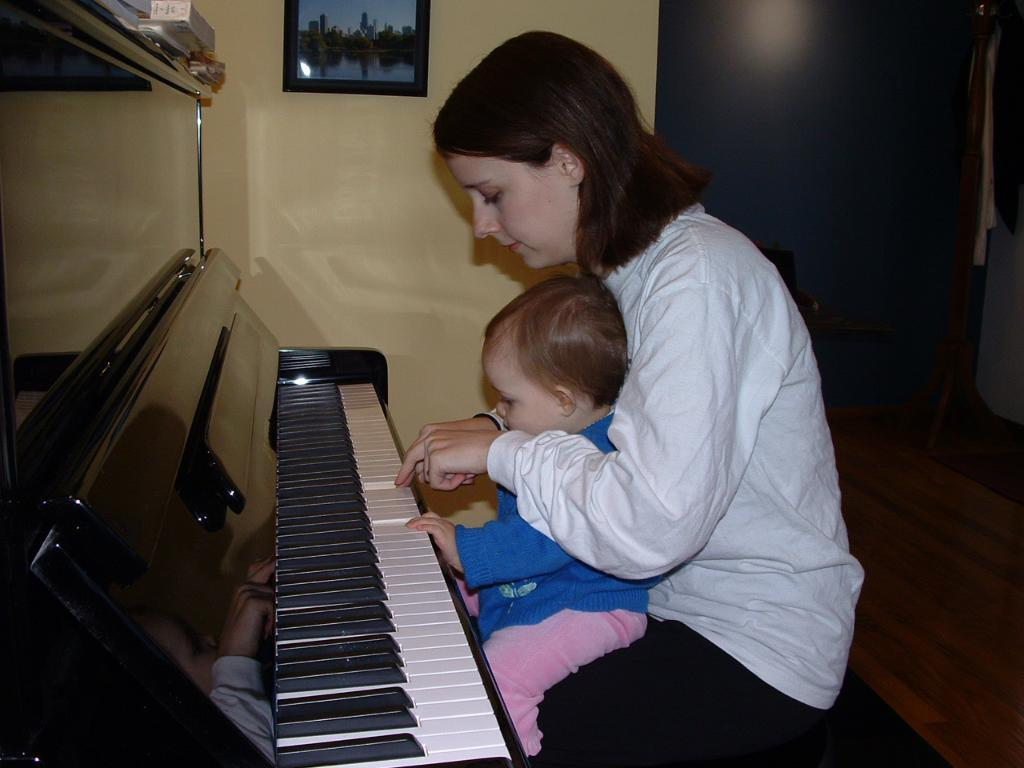Who is the main subject in the image? There is a woman in the image. What is the woman doing in the image? The woman is sitting and playing a piano. Is there anyone else with the woman in the image? Yes, the woman has a baby with her. What flavor of cream can be seen on the page of the piano in the image? There is no cream or page on the piano in the image; it is a musical instrument being played by the woman. 